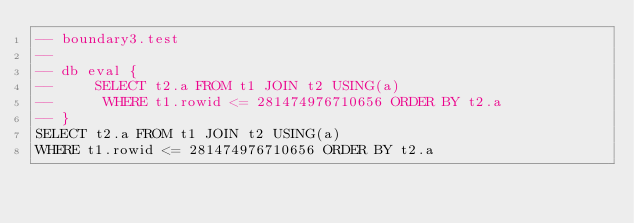Convert code to text. <code><loc_0><loc_0><loc_500><loc_500><_SQL_>-- boundary3.test
-- 
-- db eval {
--     SELECT t2.a FROM t1 JOIN t2 USING(a)
--      WHERE t1.rowid <= 281474976710656 ORDER BY t2.a
-- }
SELECT t2.a FROM t1 JOIN t2 USING(a)
WHERE t1.rowid <= 281474976710656 ORDER BY t2.a</code> 